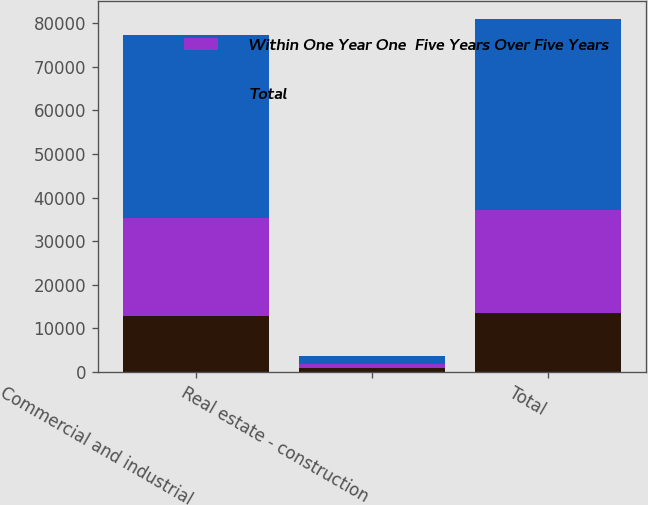Convert chart to OTSL. <chart><loc_0><loc_0><loc_500><loc_500><stacked_bar_chart><ecel><fcel>Commercial and industrial<fcel>Real estate - construction<fcel>Total<nl><fcel>nan<fcel>12742<fcel>848<fcel>13590<nl><fcel>Within One Year One  Five Years Over Five Years<fcel>22671<fcel>884<fcel>23555<nl><fcel>Total<fcel>41859<fcel>1960<fcel>43819<nl></chart> 